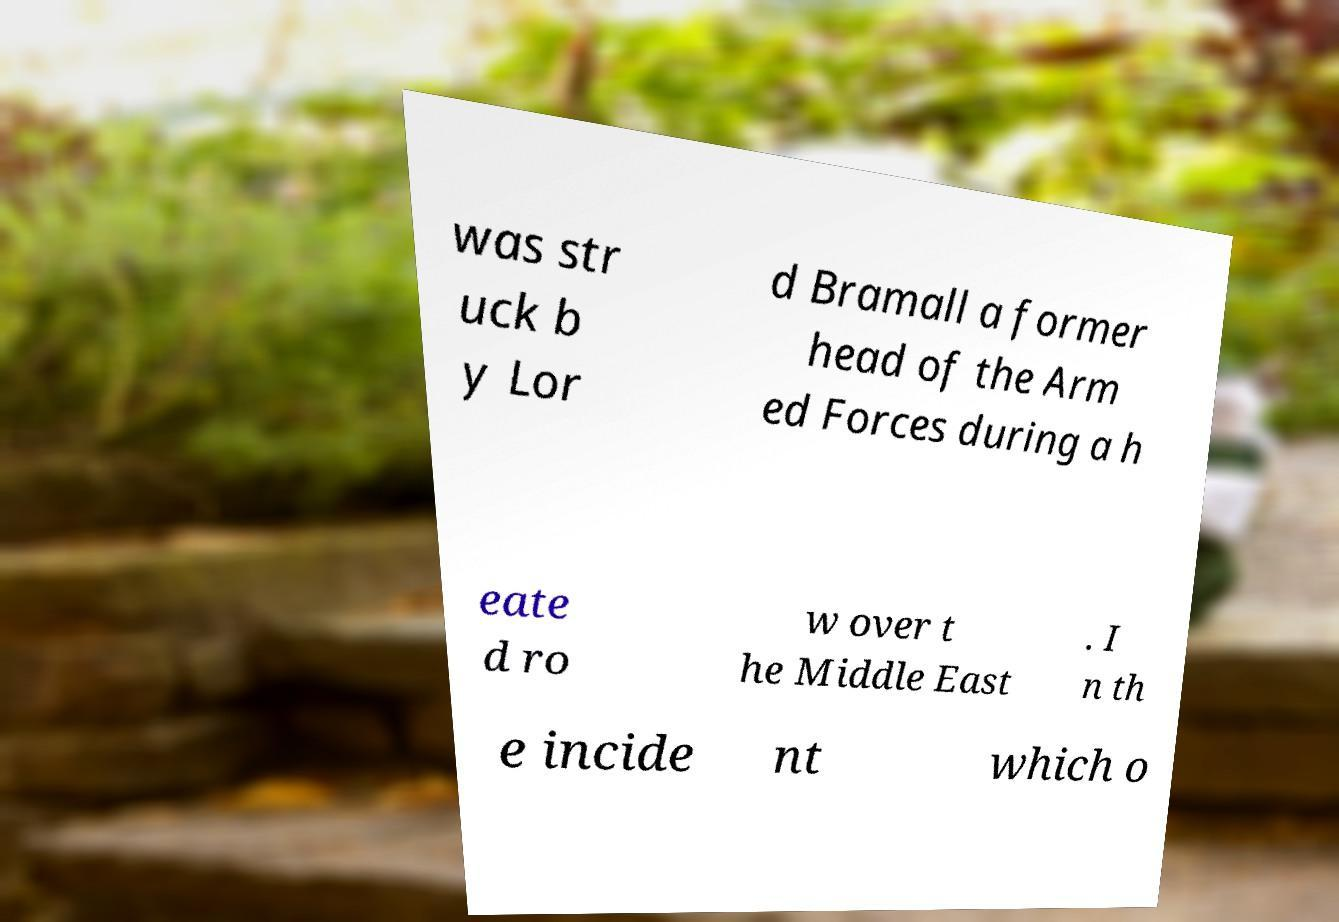Could you assist in decoding the text presented in this image and type it out clearly? was str uck b y Lor d Bramall a former head of the Arm ed Forces during a h eate d ro w over t he Middle East . I n th e incide nt which o 